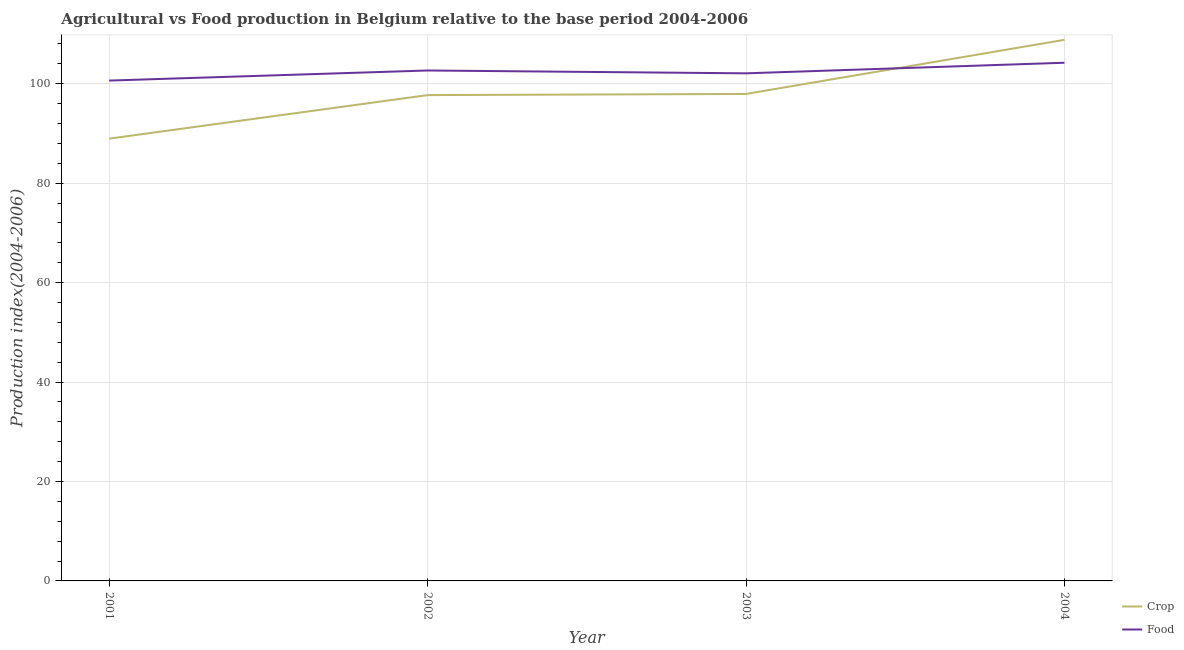Does the line corresponding to food production index intersect with the line corresponding to crop production index?
Offer a very short reply. Yes. Is the number of lines equal to the number of legend labels?
Your answer should be compact. Yes. What is the food production index in 2001?
Offer a terse response. 100.64. Across all years, what is the maximum crop production index?
Offer a very short reply. 108.84. Across all years, what is the minimum food production index?
Offer a terse response. 100.64. In which year was the food production index maximum?
Make the answer very short. 2004. What is the total crop production index in the graph?
Offer a terse response. 393.47. What is the difference between the food production index in 2001 and that in 2003?
Keep it short and to the point. -1.46. What is the difference between the crop production index in 2004 and the food production index in 2002?
Offer a very short reply. 6.17. What is the average food production index per year?
Offer a very short reply. 102.41. In the year 2001, what is the difference between the crop production index and food production index?
Offer a very short reply. -11.68. In how many years, is the crop production index greater than 76?
Provide a succinct answer. 4. What is the ratio of the crop production index in 2001 to that in 2003?
Provide a succinct answer. 0.91. What is the difference between the highest and the second highest food production index?
Keep it short and to the point. 1.56. What is the difference between the highest and the lowest crop production index?
Your response must be concise. 19.88. In how many years, is the crop production index greater than the average crop production index taken over all years?
Keep it short and to the point. 1. Is the crop production index strictly greater than the food production index over the years?
Provide a succinct answer. No. How many years are there in the graph?
Keep it short and to the point. 4. Are the values on the major ticks of Y-axis written in scientific E-notation?
Keep it short and to the point. No. Does the graph contain any zero values?
Provide a succinct answer. No. Where does the legend appear in the graph?
Your response must be concise. Bottom right. How many legend labels are there?
Offer a terse response. 2. How are the legend labels stacked?
Your response must be concise. Vertical. What is the title of the graph?
Your answer should be very brief. Agricultural vs Food production in Belgium relative to the base period 2004-2006. What is the label or title of the Y-axis?
Provide a succinct answer. Production index(2004-2006). What is the Production index(2004-2006) of Crop in 2001?
Your answer should be compact. 88.96. What is the Production index(2004-2006) in Food in 2001?
Give a very brief answer. 100.64. What is the Production index(2004-2006) in Crop in 2002?
Offer a terse response. 97.72. What is the Production index(2004-2006) of Food in 2002?
Offer a terse response. 102.67. What is the Production index(2004-2006) of Crop in 2003?
Your response must be concise. 97.95. What is the Production index(2004-2006) of Food in 2003?
Give a very brief answer. 102.1. What is the Production index(2004-2006) of Crop in 2004?
Provide a short and direct response. 108.84. What is the Production index(2004-2006) of Food in 2004?
Your answer should be compact. 104.23. Across all years, what is the maximum Production index(2004-2006) in Crop?
Your response must be concise. 108.84. Across all years, what is the maximum Production index(2004-2006) of Food?
Ensure brevity in your answer.  104.23. Across all years, what is the minimum Production index(2004-2006) in Crop?
Provide a short and direct response. 88.96. Across all years, what is the minimum Production index(2004-2006) in Food?
Give a very brief answer. 100.64. What is the total Production index(2004-2006) of Crop in the graph?
Give a very brief answer. 393.47. What is the total Production index(2004-2006) in Food in the graph?
Offer a very short reply. 409.64. What is the difference between the Production index(2004-2006) in Crop in 2001 and that in 2002?
Your response must be concise. -8.76. What is the difference between the Production index(2004-2006) in Food in 2001 and that in 2002?
Keep it short and to the point. -2.03. What is the difference between the Production index(2004-2006) in Crop in 2001 and that in 2003?
Offer a very short reply. -8.99. What is the difference between the Production index(2004-2006) in Food in 2001 and that in 2003?
Provide a short and direct response. -1.46. What is the difference between the Production index(2004-2006) of Crop in 2001 and that in 2004?
Your response must be concise. -19.88. What is the difference between the Production index(2004-2006) in Food in 2001 and that in 2004?
Offer a very short reply. -3.59. What is the difference between the Production index(2004-2006) of Crop in 2002 and that in 2003?
Provide a short and direct response. -0.23. What is the difference between the Production index(2004-2006) of Food in 2002 and that in 2003?
Your response must be concise. 0.57. What is the difference between the Production index(2004-2006) of Crop in 2002 and that in 2004?
Your answer should be very brief. -11.12. What is the difference between the Production index(2004-2006) of Food in 2002 and that in 2004?
Give a very brief answer. -1.56. What is the difference between the Production index(2004-2006) of Crop in 2003 and that in 2004?
Provide a short and direct response. -10.89. What is the difference between the Production index(2004-2006) in Food in 2003 and that in 2004?
Give a very brief answer. -2.13. What is the difference between the Production index(2004-2006) of Crop in 2001 and the Production index(2004-2006) of Food in 2002?
Offer a very short reply. -13.71. What is the difference between the Production index(2004-2006) of Crop in 2001 and the Production index(2004-2006) of Food in 2003?
Make the answer very short. -13.14. What is the difference between the Production index(2004-2006) in Crop in 2001 and the Production index(2004-2006) in Food in 2004?
Provide a succinct answer. -15.27. What is the difference between the Production index(2004-2006) in Crop in 2002 and the Production index(2004-2006) in Food in 2003?
Your response must be concise. -4.38. What is the difference between the Production index(2004-2006) in Crop in 2002 and the Production index(2004-2006) in Food in 2004?
Provide a short and direct response. -6.51. What is the difference between the Production index(2004-2006) of Crop in 2003 and the Production index(2004-2006) of Food in 2004?
Make the answer very short. -6.28. What is the average Production index(2004-2006) of Crop per year?
Offer a terse response. 98.37. What is the average Production index(2004-2006) in Food per year?
Offer a terse response. 102.41. In the year 2001, what is the difference between the Production index(2004-2006) of Crop and Production index(2004-2006) of Food?
Make the answer very short. -11.68. In the year 2002, what is the difference between the Production index(2004-2006) of Crop and Production index(2004-2006) of Food?
Provide a succinct answer. -4.95. In the year 2003, what is the difference between the Production index(2004-2006) in Crop and Production index(2004-2006) in Food?
Keep it short and to the point. -4.15. In the year 2004, what is the difference between the Production index(2004-2006) in Crop and Production index(2004-2006) in Food?
Your response must be concise. 4.61. What is the ratio of the Production index(2004-2006) of Crop in 2001 to that in 2002?
Your response must be concise. 0.91. What is the ratio of the Production index(2004-2006) of Food in 2001 to that in 2002?
Give a very brief answer. 0.98. What is the ratio of the Production index(2004-2006) of Crop in 2001 to that in 2003?
Make the answer very short. 0.91. What is the ratio of the Production index(2004-2006) of Food in 2001 to that in 2003?
Provide a short and direct response. 0.99. What is the ratio of the Production index(2004-2006) in Crop in 2001 to that in 2004?
Ensure brevity in your answer.  0.82. What is the ratio of the Production index(2004-2006) in Food in 2001 to that in 2004?
Make the answer very short. 0.97. What is the ratio of the Production index(2004-2006) of Crop in 2002 to that in 2003?
Provide a short and direct response. 1. What is the ratio of the Production index(2004-2006) in Food in 2002 to that in 2003?
Provide a succinct answer. 1.01. What is the ratio of the Production index(2004-2006) of Crop in 2002 to that in 2004?
Offer a very short reply. 0.9. What is the ratio of the Production index(2004-2006) of Crop in 2003 to that in 2004?
Your response must be concise. 0.9. What is the ratio of the Production index(2004-2006) of Food in 2003 to that in 2004?
Your answer should be very brief. 0.98. What is the difference between the highest and the second highest Production index(2004-2006) in Crop?
Offer a terse response. 10.89. What is the difference between the highest and the second highest Production index(2004-2006) in Food?
Offer a very short reply. 1.56. What is the difference between the highest and the lowest Production index(2004-2006) of Crop?
Your answer should be very brief. 19.88. What is the difference between the highest and the lowest Production index(2004-2006) in Food?
Your answer should be compact. 3.59. 